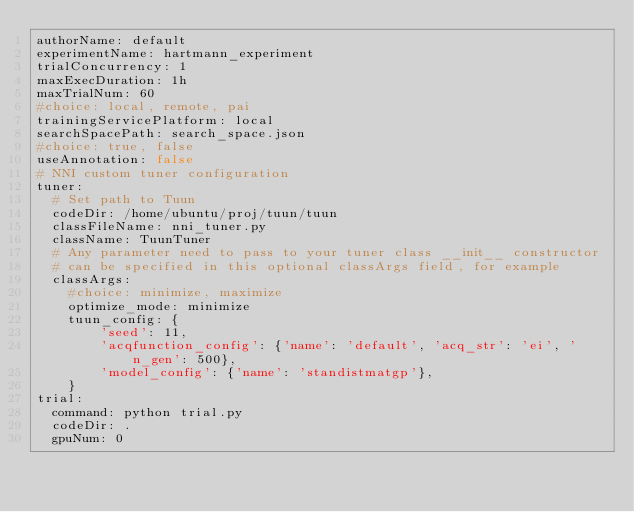<code> <loc_0><loc_0><loc_500><loc_500><_YAML_>authorName: default
experimentName: hartmann_experiment
trialConcurrency: 1
maxExecDuration: 1h
maxTrialNum: 60
#choice: local, remote, pai
trainingServicePlatform: local
searchSpacePath: search_space.json
#choice: true, false
useAnnotation: false
# NNI custom tuner configuration
tuner:
  # Set path to Tuun
  codeDir: /home/ubuntu/proj/tuun/tuun
  classFileName: nni_tuner.py
  className: TuunTuner
  # Any parameter need to pass to your tuner class __init__ constructor
  # can be specified in this optional classArgs field, for example
  classArgs:
    #choice: minimize, maximize
    optimize_mode: minimize
    tuun_config: {
        'seed': 11,
        'acqfunction_config': {'name': 'default', 'acq_str': 'ei', 'n_gen': 500},
        'model_config': {'name': 'standistmatgp'},
    } 
trial:
  command: python trial.py
  codeDir: .
  gpuNum: 0
</code> 